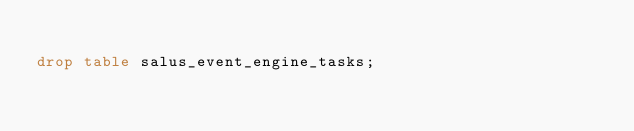<code> <loc_0><loc_0><loc_500><loc_500><_SQL_>
drop table salus_event_engine_tasks;</code> 